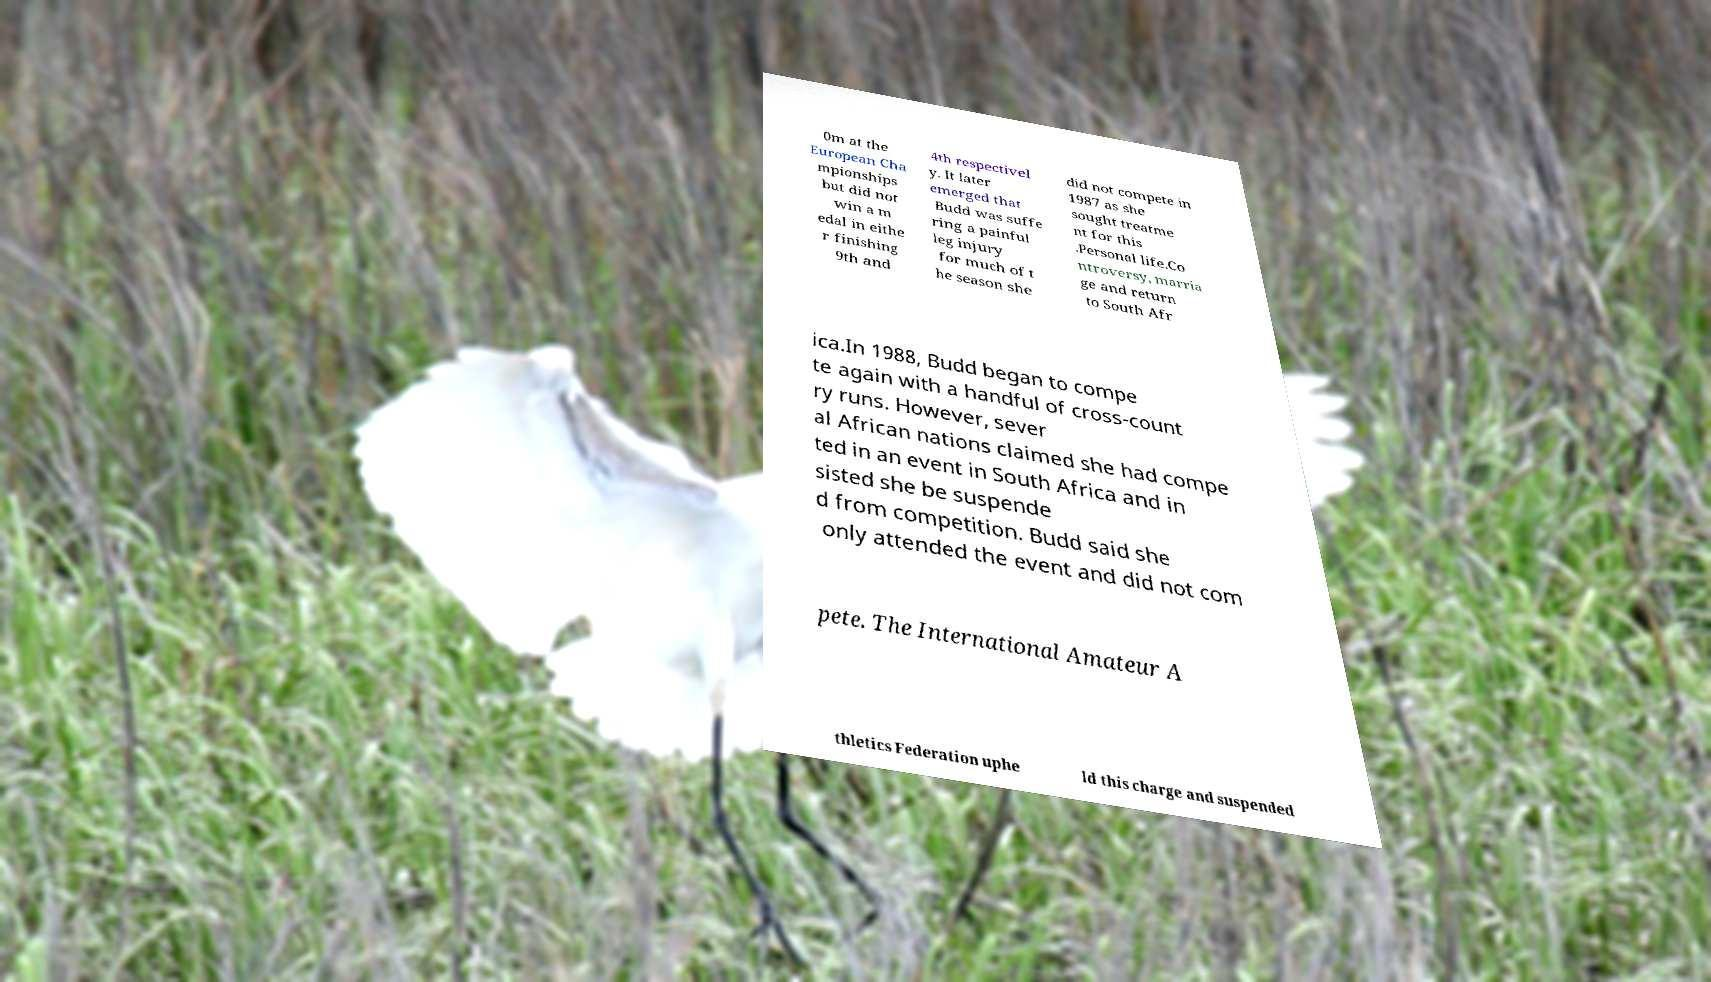Can you read and provide the text displayed in the image?This photo seems to have some interesting text. Can you extract and type it out for me? 0m at the European Cha mpionships but did not win a m edal in eithe r finishing 9th and 4th respectivel y. It later emerged that Budd was suffe ring a painful leg injury for much of t he season she did not compete in 1987 as she sought treatme nt for this .Personal life.Co ntroversy, marria ge and return to South Afr ica.In 1988, Budd began to compe te again with a handful of cross-count ry runs. However, sever al African nations claimed she had compe ted in an event in South Africa and in sisted she be suspende d from competition. Budd said she only attended the event and did not com pete. The International Amateur A thletics Federation uphe ld this charge and suspended 